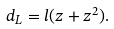<formula> <loc_0><loc_0><loc_500><loc_500>d _ { L } = l ( z + z ^ { 2 } ) .</formula> 